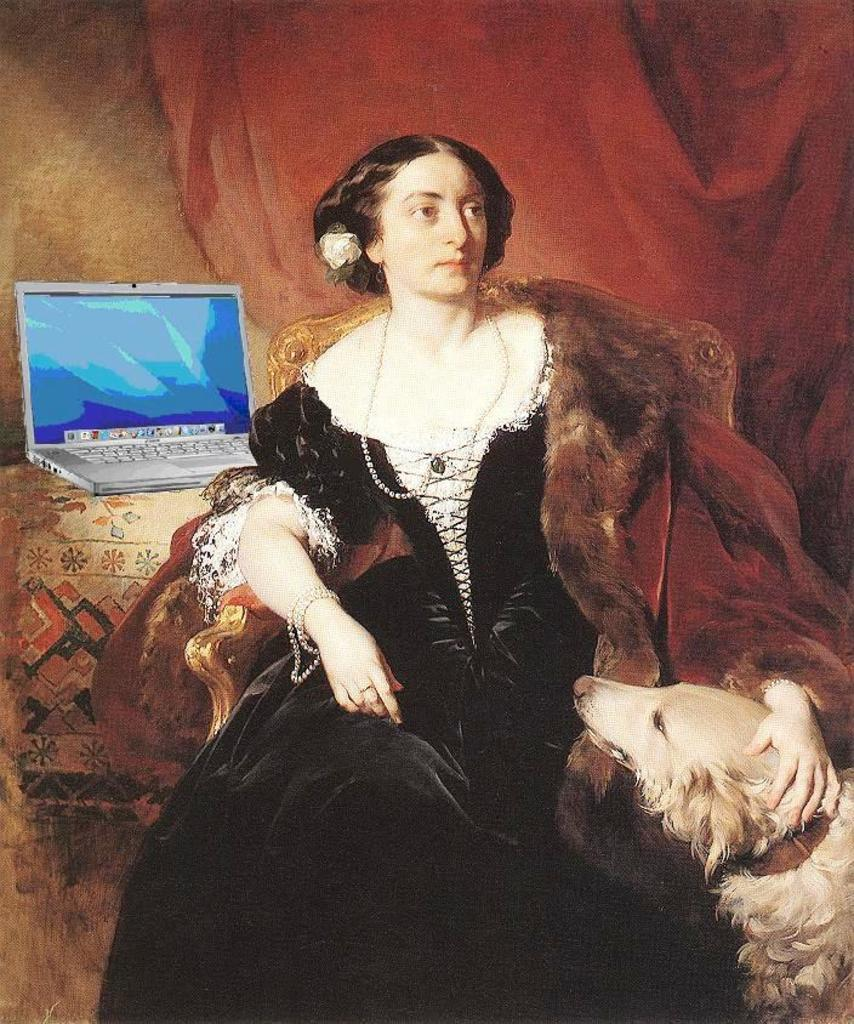What type of artwork is depicted in the image? The image is a painting. What is the woman in the painting doing? The woman is sitting on a chair in the painting. What object is beside the woman? There is a laptop beside the woman. What animal can be seen on the right side of the painting? There is a dog on the right side of the painting. What type of ball is being used at the party in the painting? There is no ball or party present in the painting; it features a woman sitting on a chair with a laptop and a dog. 